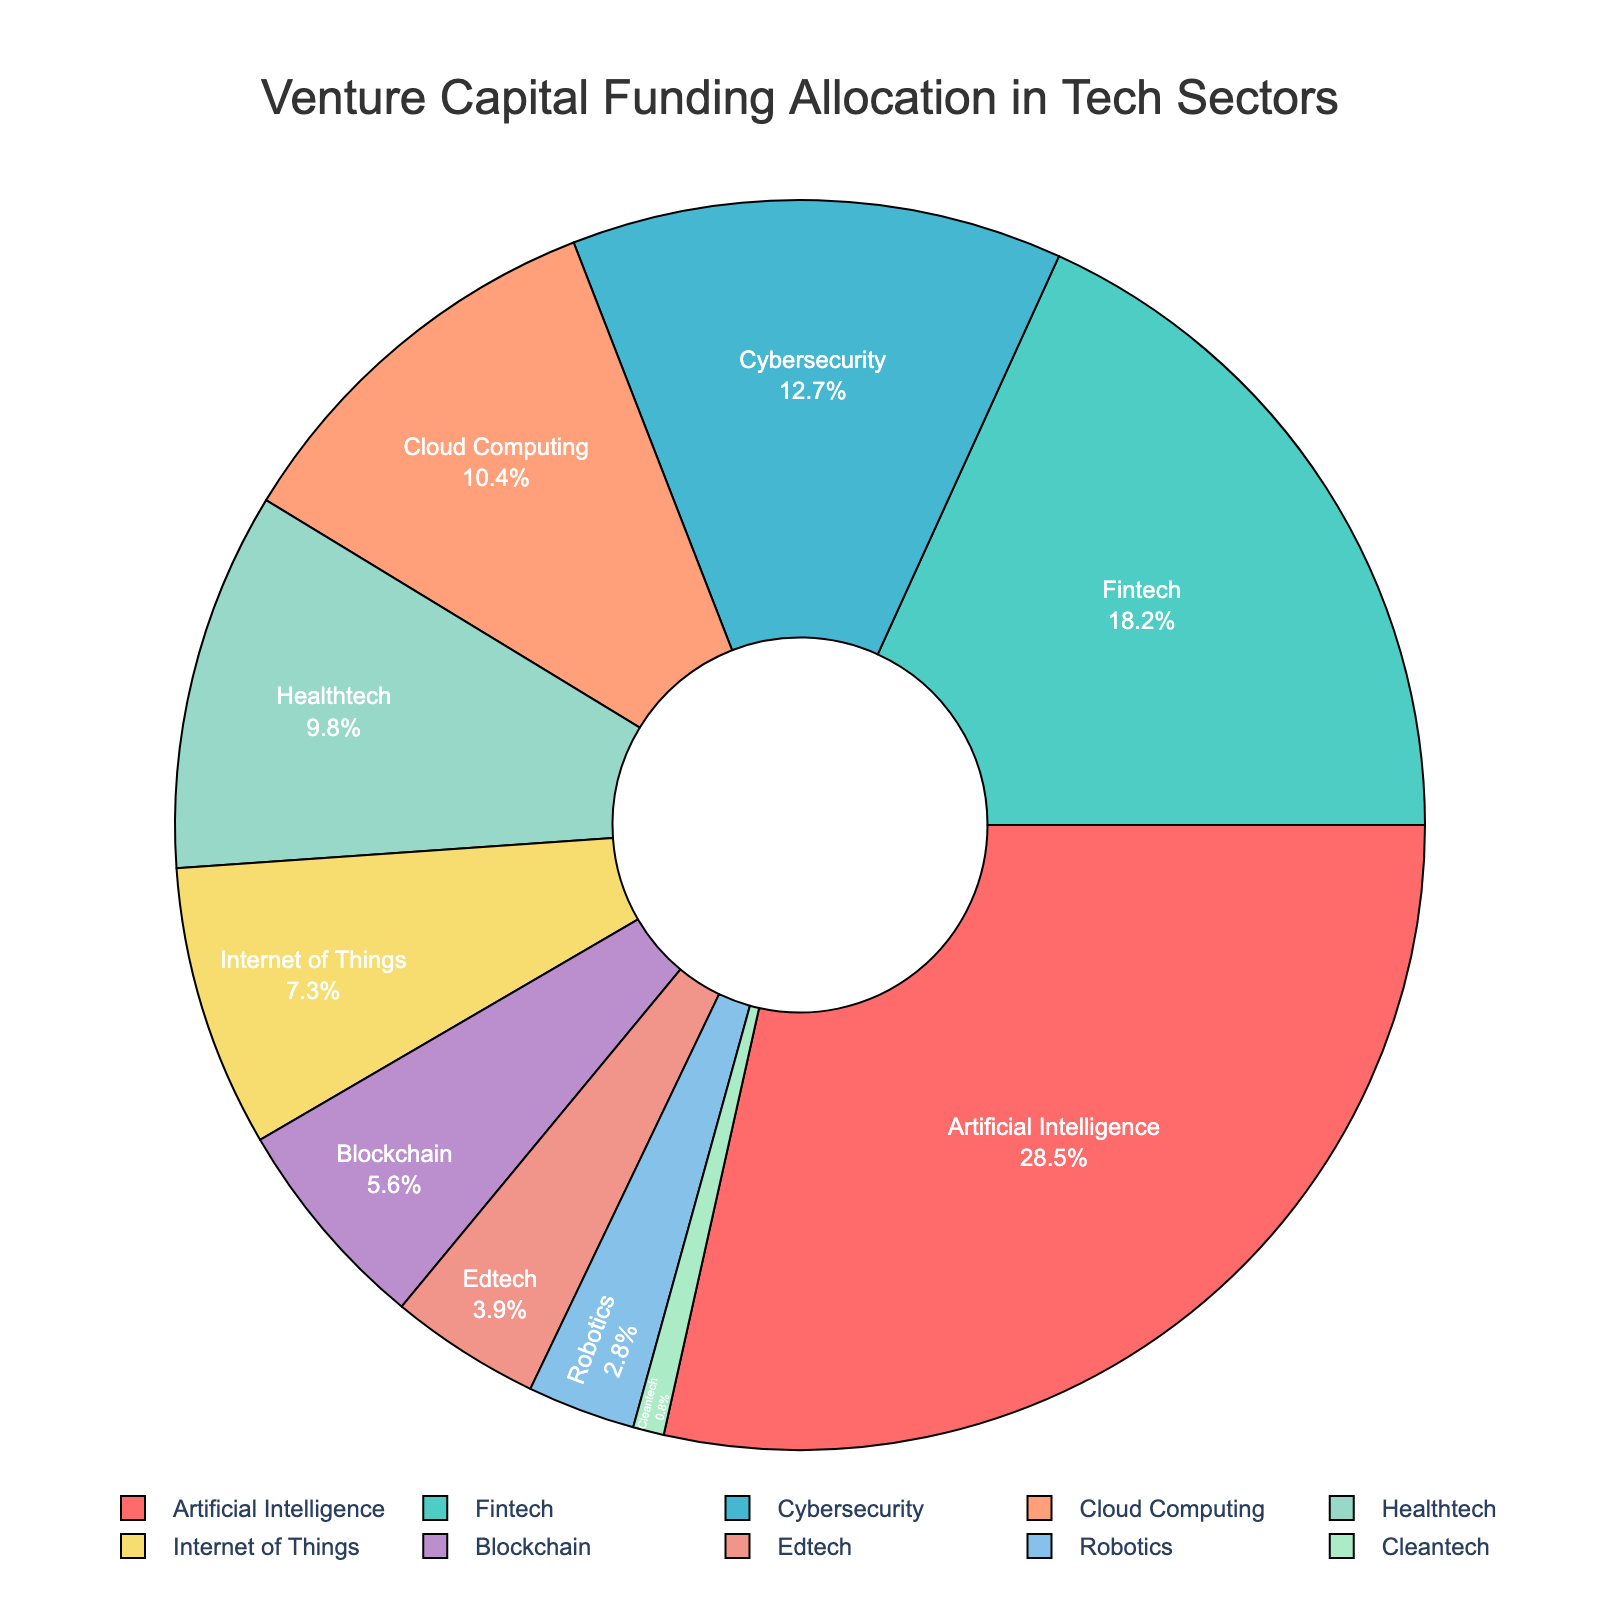What sector receives the highest percentage of funding? The largest segment in the pie chart represents the sector with the highest funding, and it is labeled as "Artificial Intelligence" with 28.5%.
Answer: Artificial Intelligence Which two sectors have the closest funding percentages, and what are those percentages? Healthtech and Internet of Things have the closest funding percentages with 9.8% and 7.3% respectively, as their slices appear visually similar in size in the pie chart.
Answer: Healthtech: 9.8%, Internet of Things: 7.3% What is the total percentage of funding allocated to Fintech and Cybersecurity combined? The funding percentage for Fintech is 18.2% and for Cybersecurity is 12.7%. Combined, 18.2 + 12.7 = 30.9%.
Answer: 30.9% Is the funding for Blockchain greater than the funding for Edtech? By comparing the sizes of the slices labeled "Blockchain" (5.6%) and "Edtech" (3.9%), Blockchain's funding percentage is greater than Edtech's.
Answer: Yes What’s the smallest funding percentage displayed and which sector does it correspond to? The smallest slice in the pie chart represents the sector with the smallest funding percentage. It is labeled as "Clean tech" with 0.8%.
Answer: Cleantech, 0.8% How much more funding percentage does Artificial Intelligence receive compared to Robotics? Artificial Intelligence receives 28.5%, and Robotics receives 2.8%. Therefore, 28.5 - 2.8 = 25.7% more funding.
Answer: 25.7% What is the sum of the funding percentages allocated to Cybersecurity, Cloud Computing, and Healthtech? Summing the percentages: Cybersecurity (12.7%), Cloud Computing (10.4%), and Healthtech (9.8%) gives 12.7 + 10.4 + 9.8 = 32.9%.
Answer: 32.9% If we group Internet of Things, Blockchain, Edtech, and Cleantech together, what is their total funding percentage? Adding the funding percentages: Internet of Things (7.3%), Blockchain (5.6%), Edtech (3.9%), Cleantech (0.8%) gives 7.3 + 5.6 + 3.9 + 0.8 = 17.6%.
Answer: 17.6% Which sectors are represented by the blue and purple slices? The blue and purple slices are labeled as "Internet of Things" (blue) and "Blockchain" (purple) in the pie chart.
Answer: Internet of Things, Blockchain 